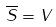Convert formula to latex. <formula><loc_0><loc_0><loc_500><loc_500>\overline { S } = V</formula> 